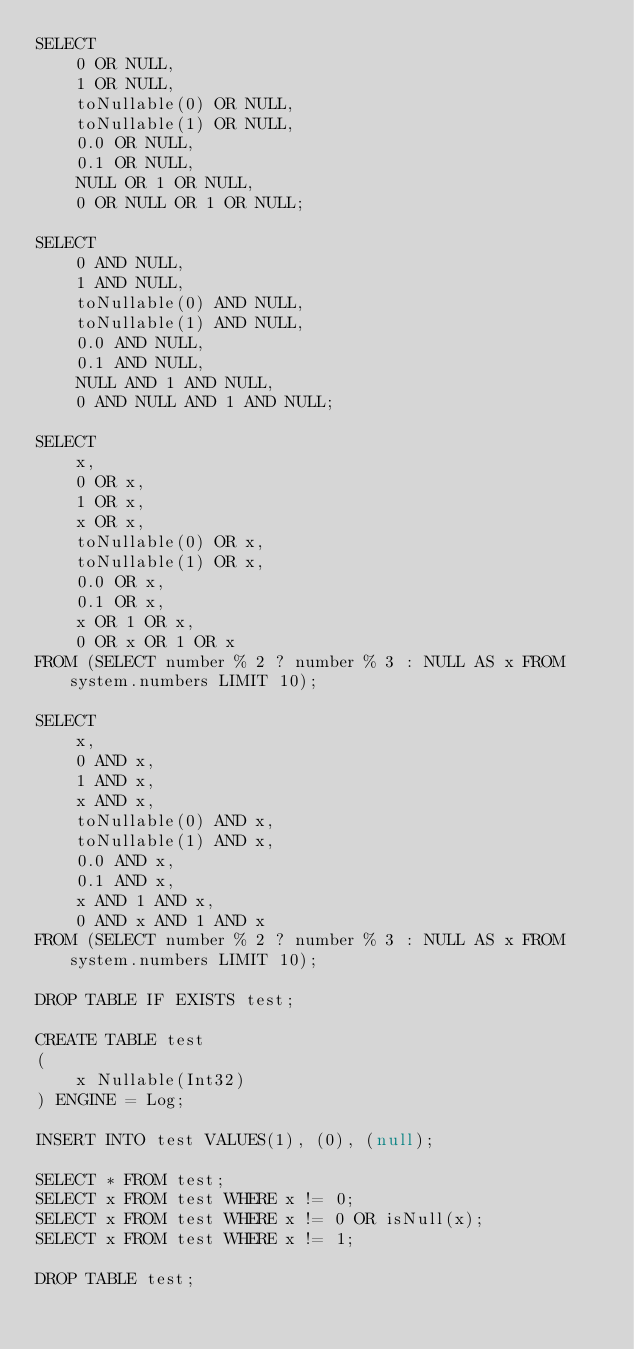Convert code to text. <code><loc_0><loc_0><loc_500><loc_500><_SQL_>SELECT
    0 OR NULL,
    1 OR NULL,
    toNullable(0) OR NULL,
    toNullable(1) OR NULL,
    0.0 OR NULL,
    0.1 OR NULL,
    NULL OR 1 OR NULL,
    0 OR NULL OR 1 OR NULL;

SELECT
    0 AND NULL,
    1 AND NULL,
    toNullable(0) AND NULL,
    toNullable(1) AND NULL,
    0.0 AND NULL,
    0.1 AND NULL,
    NULL AND 1 AND NULL,
    0 AND NULL AND 1 AND NULL;

SELECT
    x,
    0 OR x,
    1 OR x,
    x OR x,
    toNullable(0) OR x,
    toNullable(1) OR x,
    0.0 OR x,
    0.1 OR x,
    x OR 1 OR x,
    0 OR x OR 1 OR x
FROM (SELECT number % 2 ? number % 3 : NULL AS x FROM system.numbers LIMIT 10);

SELECT
    x,
    0 AND x,
    1 AND x,
    x AND x,
    toNullable(0) AND x,
    toNullable(1) AND x,
    0.0 AND x,
    0.1 AND x,
    x AND 1 AND x,
    0 AND x AND 1 AND x
FROM (SELECT number % 2 ? number % 3 : NULL AS x FROM system.numbers LIMIT 10);

DROP TABLE IF EXISTS test;

CREATE TABLE test
(
    x Nullable(Int32)
) ENGINE = Log;

INSERT INTO test VALUES(1), (0), (null);

SELECT * FROM test;
SELECT x FROM test WHERE x != 0;
SELECT x FROM test WHERE x != 0 OR isNull(x);
SELECT x FROM test WHERE x != 1;

DROP TABLE test;
</code> 